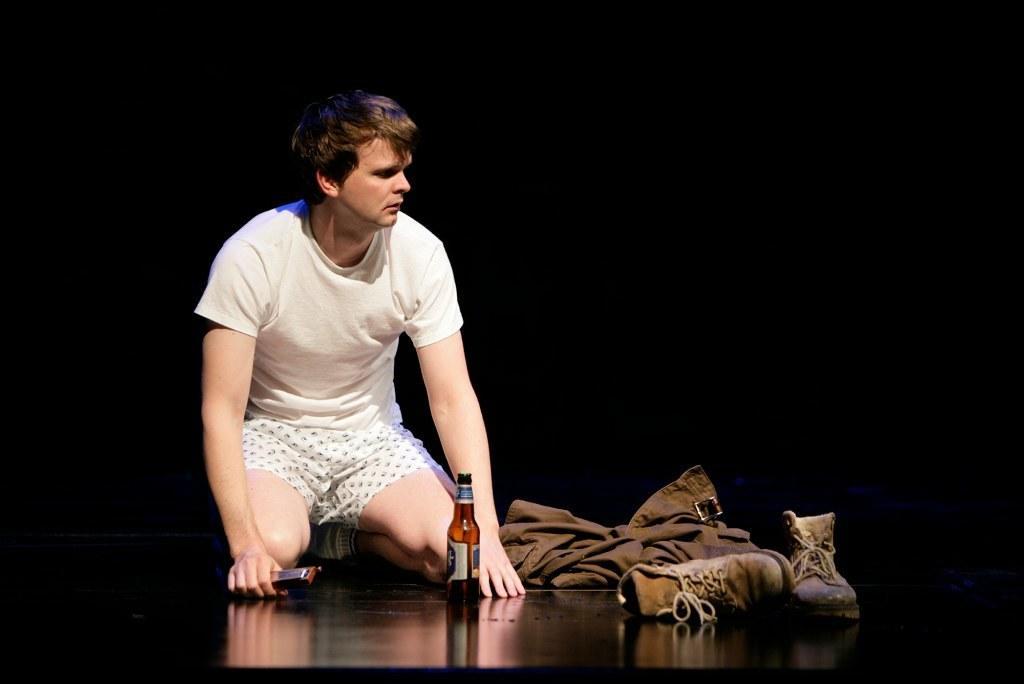Please provide a concise description of this image. In this image we can see a person on the floor. Here we can see a jacket and shoes which are on the right side. Here we can see a bottle. 